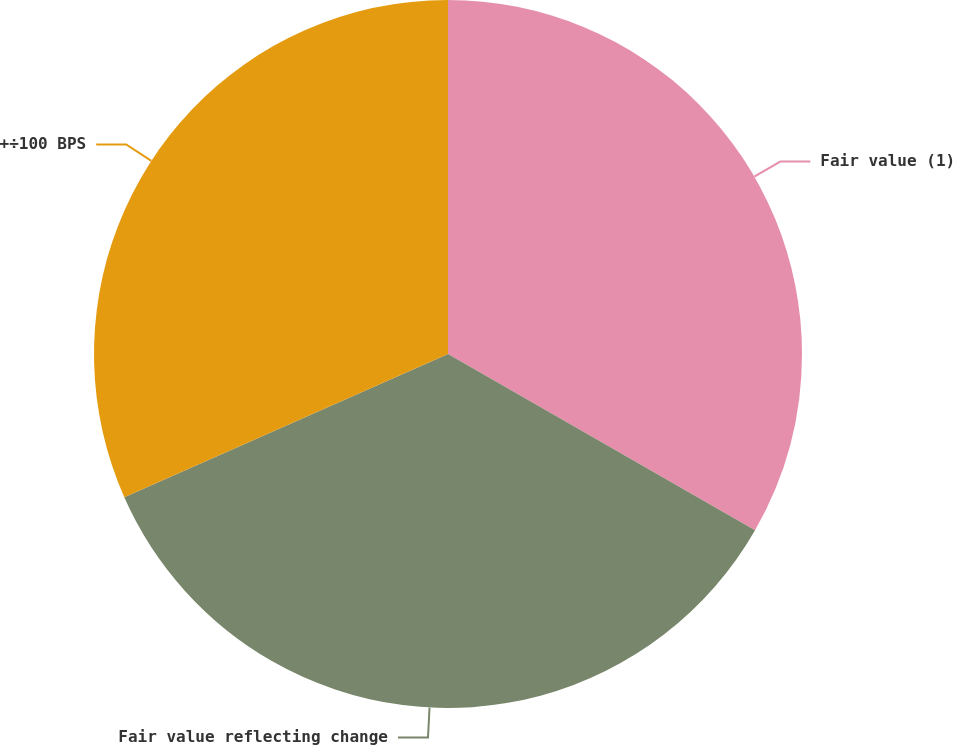Convert chart to OTSL. <chart><loc_0><loc_0><loc_500><loc_500><pie_chart><fcel>Fair value (1)<fcel>Fair value reflecting change<fcel>+÷100 BPS<nl><fcel>33.29%<fcel>35.08%<fcel>31.63%<nl></chart> 